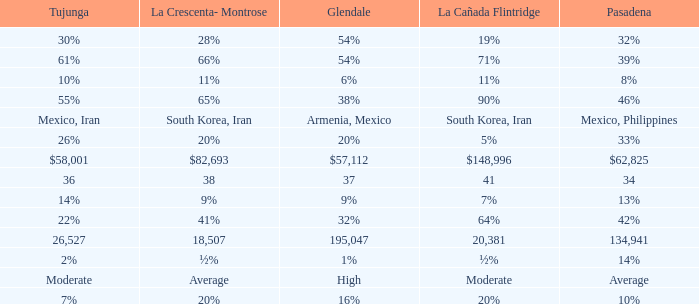What is the figure for Tujunga when Pasadena is 134,941? 26527.0. 